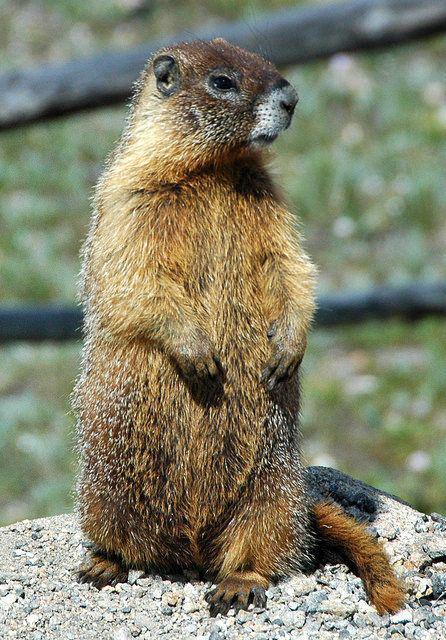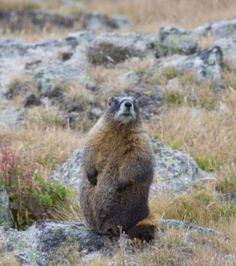The first image is the image on the left, the second image is the image on the right. Analyze the images presented: Is the assertion "At least one image features a rodent-type animal standing upright." valid? Answer yes or no. Yes. 